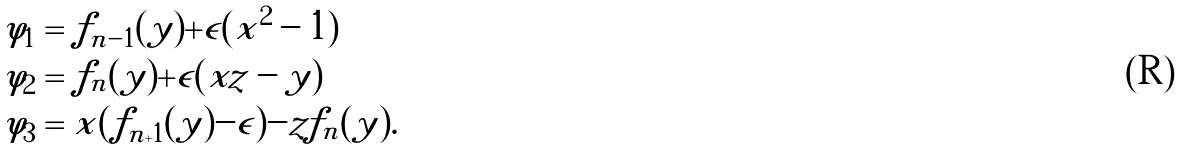<formula> <loc_0><loc_0><loc_500><loc_500>\varphi _ { 1 } & = f _ { n - 1 } ( y ) + \epsilon ( x ^ { 2 } - 1 ) \\ \varphi _ { 2 } & = f _ { n } ( y ) + \epsilon ( x z - y ) \\ \varphi _ { 3 } & = x ( f _ { n + 1 } ( y ) - \epsilon ) - z f _ { n } ( y ) .</formula> 